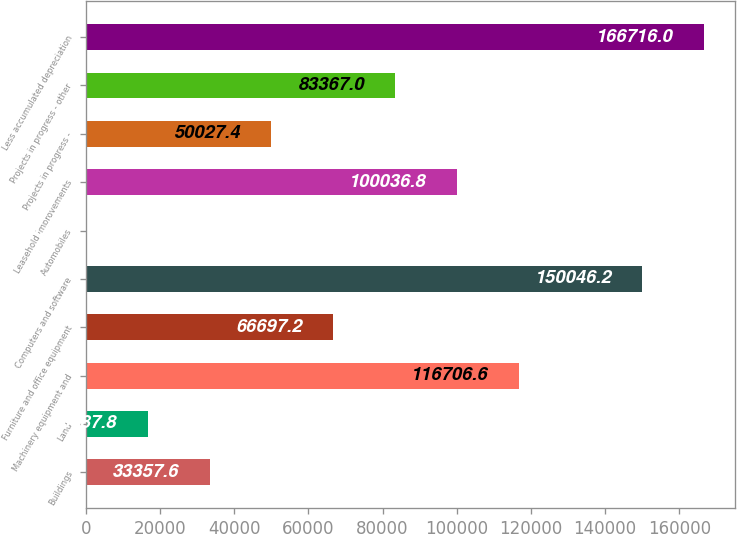Convert chart to OTSL. <chart><loc_0><loc_0><loc_500><loc_500><bar_chart><fcel>Buildings<fcel>Land<fcel>Machinery equipment and<fcel>Furniture and office equipment<fcel>Computers and software<fcel>Automobiles<fcel>Leasehold improvements<fcel>Projects in progress -<fcel>Projects in progress - other<fcel>Less accumulated depreciation<nl><fcel>33357.6<fcel>16687.8<fcel>116707<fcel>66697.2<fcel>150046<fcel>18<fcel>100037<fcel>50027.4<fcel>83367<fcel>166716<nl></chart> 